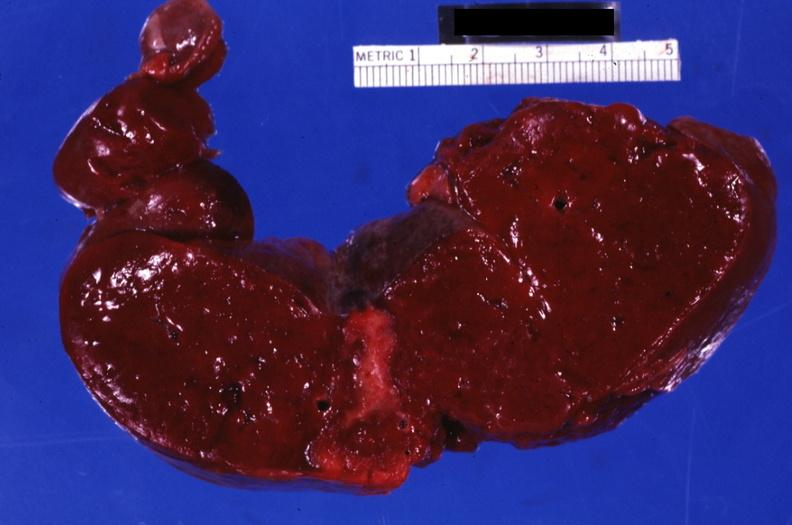what well shown healing infarct?
Answer the question using a single word or phrase. Section through spleen with large 